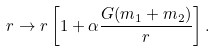Convert formula to latex. <formula><loc_0><loc_0><loc_500><loc_500>r \rightarrow r \left [ 1 + \alpha \frac { G ( m _ { 1 } + m _ { 2 } ) } { r } \right ] .</formula> 